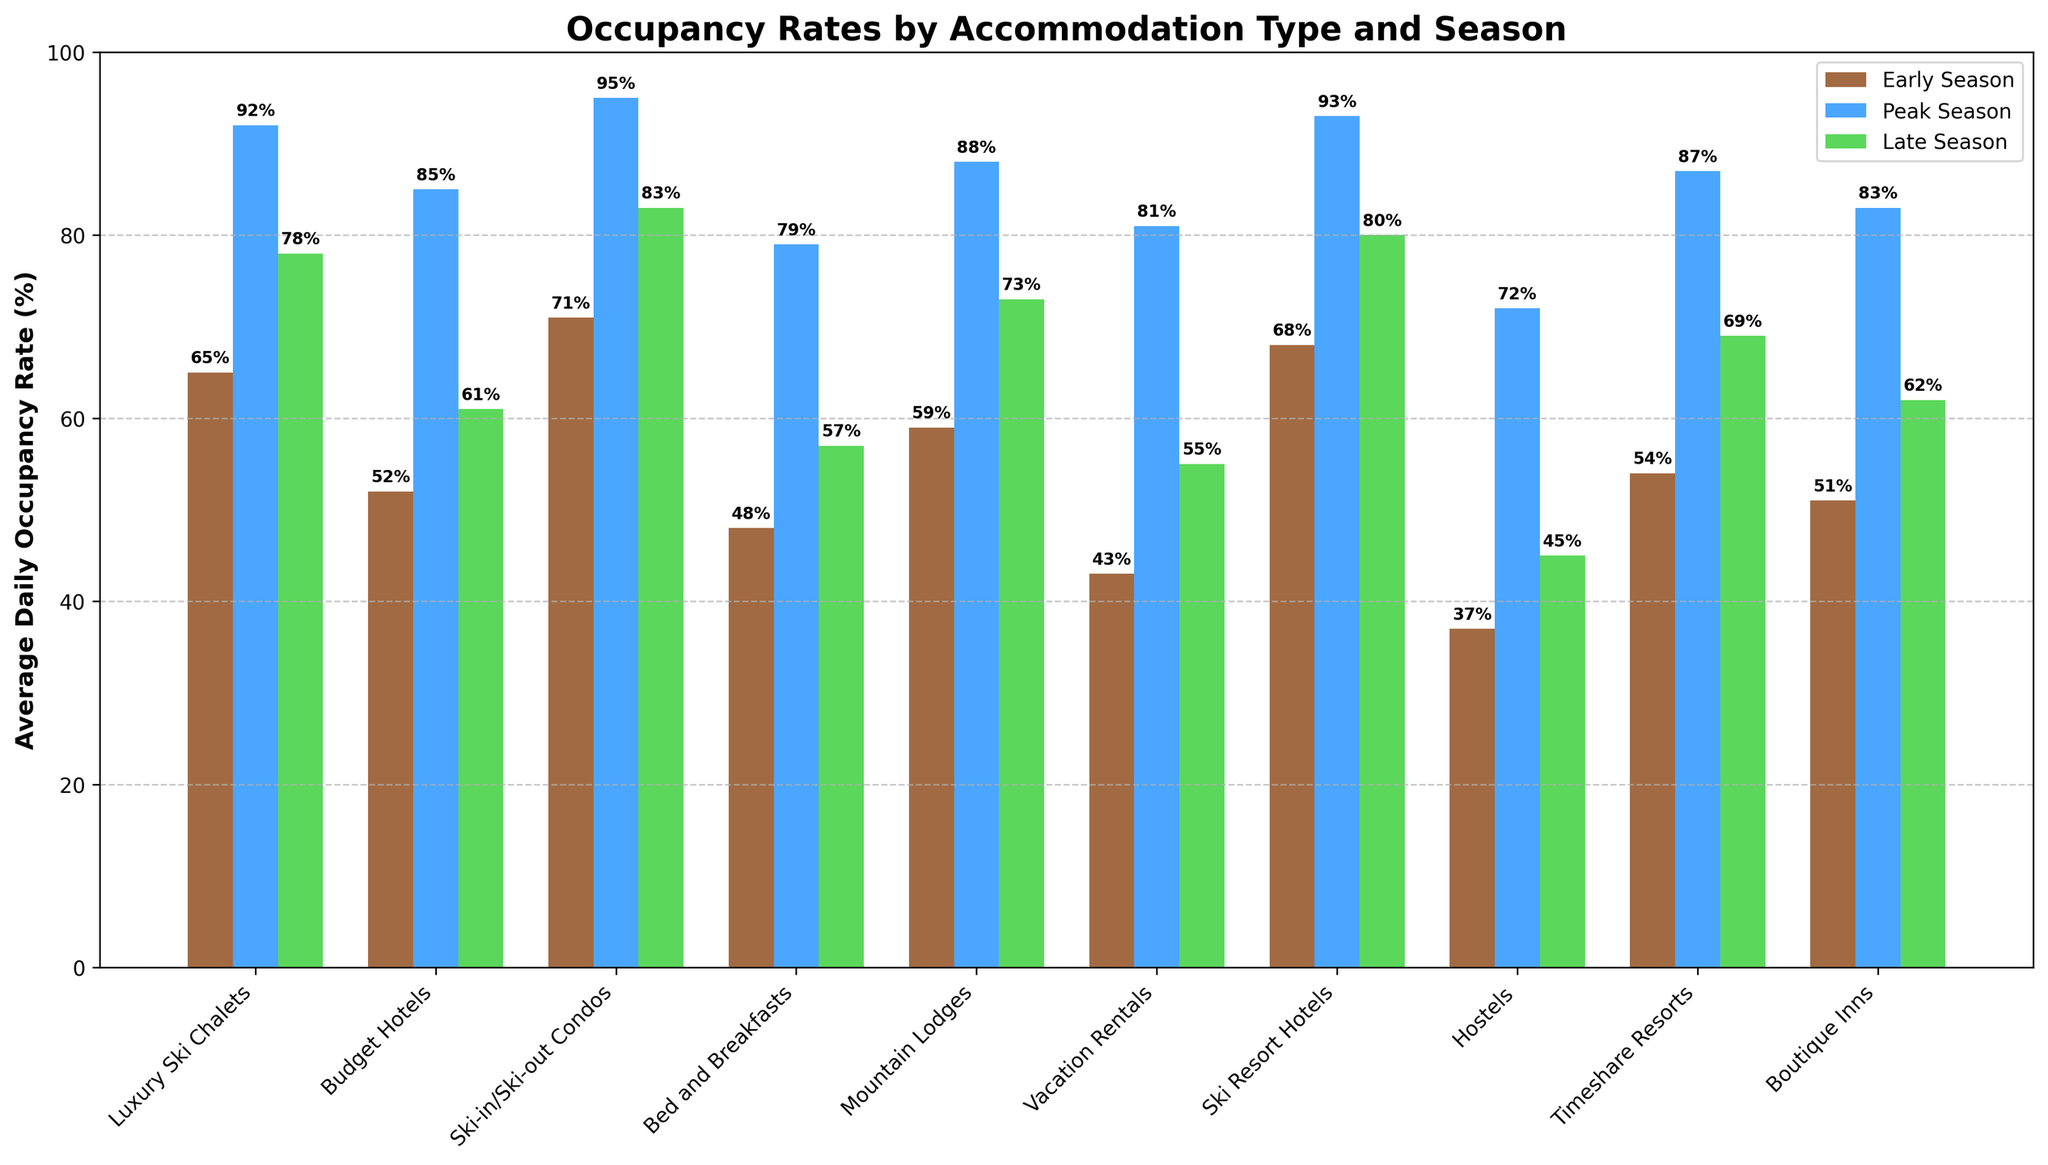What is the highest occupancy rate during the peak season? Looking at the peak season bars (in blue) for all accommodation types, the highest bar represents Ski-in/Ski-out Condos with an occupancy rate of 95%.
Answer: 95% Which type of accommodation has the lowest occupancy rate in the early season? Observing the early season bars (in brown) for all accommodation types, the shortest bar represents Hostels with an occupancy rate of 37%.
Answer: Hostels How does the occupancy rate of Bed and Breakfasts in the late season compare to that of Budget Hotels in the same season? Looking at the green bars representing the late season, Bed and Breakfasts have a rate of 57%, whereas Budget Hotels have a rate of 61%. Budget Hotels are higher by 4%.
Answer: Budget Hotels are higher by 4% What is the average occupancy rate across all accommodations in the peak season? Sum all the blue bars (peak season) and divide by the number of accommodation types: (92 + 85 + 95 + 79 + 88 + 81 + 93 + 72 + 87 + 83) / 10 = 85.5%.
Answer: 85.5% Which accommodations have more than 80% occupancy in the late season? Observing the green bars, the accommodations with heights above 80% are Ski-in/Ski-out Condos (83%), Ski Resort Hotels (80%), and Luxury Ski Chalets (78%).
Answer: Ski-in/Ski-out Condos, Ski Resort Hotels What is the difference in the occupancy rates of Ski Resort Hotels between the early season and the peak season? The bar for Ski Resort Hotels in the early season is 68%, and in the peak season is 93%. The difference is 93% - 68% = 25%.
Answer: 25% Which accommodation type shows the greatest increase in occupancy rate from early season to peak season? Calculate the difference for each accommodation type between early and peak seasons and find the highest. Ski Resort Hotels: 93 - 68 = 25%, Bed and Breakfasts: 79 - 48 = 31%, etc. Bed and Breakfasts have the greatest increase of 31%.
Answer: Bed and Breakfasts What is the total occupancy rate for Luxury Ski Chalets across all seasons? Sum the occupancy rates of Luxury Ski Chalets: 65 (early) + 92 (peak) + 78 (late) = 235%.
Answer: 235% Which season has the highest variability in occupancy rates across all types of accommodations? Calculate the range (max - min) for each season: Early Season: 71-37=34%, Peak Season: 95-72=23%, Late Season: 83-45=38%. Late Season has the highest variability.
Answer: Late Season 